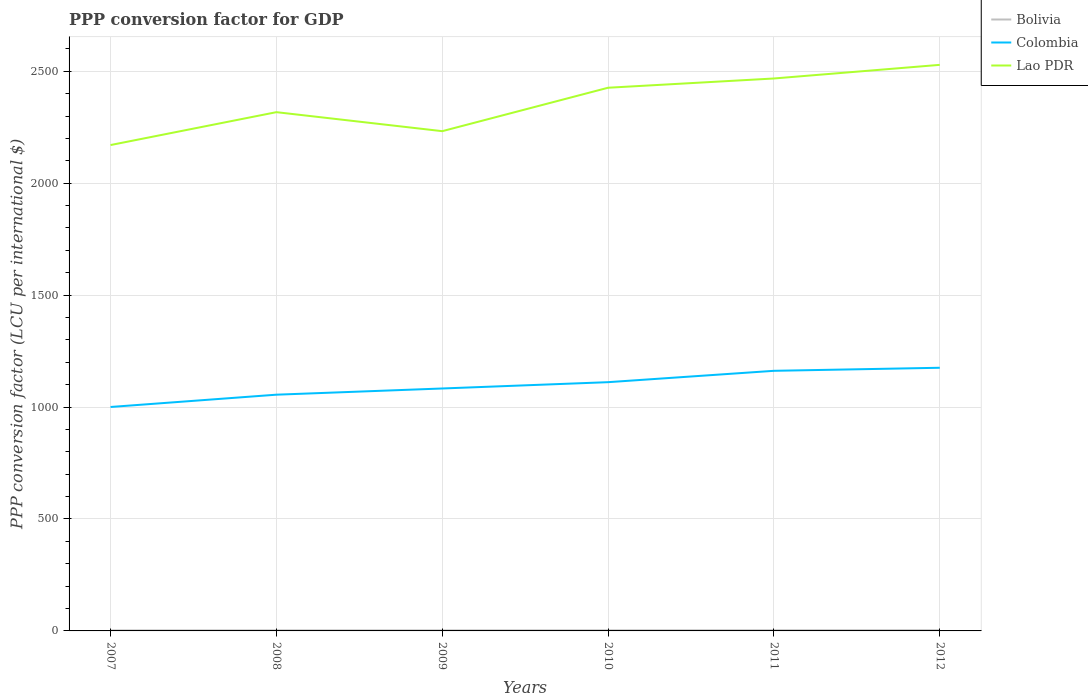Does the line corresponding to Lao PDR intersect with the line corresponding to Colombia?
Ensure brevity in your answer.  No. Is the number of lines equal to the number of legend labels?
Provide a succinct answer. Yes. Across all years, what is the maximum PPP conversion factor for GDP in Lao PDR?
Keep it short and to the point. 2170.38. In which year was the PPP conversion factor for GDP in Colombia maximum?
Offer a very short reply. 2007. What is the total PPP conversion factor for GDP in Bolivia in the graph?
Ensure brevity in your answer.  0.08. What is the difference between the highest and the second highest PPP conversion factor for GDP in Bolivia?
Offer a very short reply. 0.77. What is the difference between the highest and the lowest PPP conversion factor for GDP in Colombia?
Offer a very short reply. 3. How many lines are there?
Offer a terse response. 3. What is the difference between two consecutive major ticks on the Y-axis?
Offer a very short reply. 500. Does the graph contain any zero values?
Offer a terse response. No. Where does the legend appear in the graph?
Offer a terse response. Top right. How are the legend labels stacked?
Give a very brief answer. Vertical. What is the title of the graph?
Ensure brevity in your answer.  PPP conversion factor for GDP. What is the label or title of the Y-axis?
Offer a terse response. PPP conversion factor (LCU per international $). What is the PPP conversion factor (LCU per international $) in Bolivia in 2007?
Give a very brief answer. 2.33. What is the PPP conversion factor (LCU per international $) in Colombia in 2007?
Your response must be concise. 1000.36. What is the PPP conversion factor (LCU per international $) in Lao PDR in 2007?
Offer a very short reply. 2170.38. What is the PPP conversion factor (LCU per international $) in Bolivia in 2008?
Offer a terse response. 2.52. What is the PPP conversion factor (LCU per international $) of Colombia in 2008?
Keep it short and to the point. 1055.24. What is the PPP conversion factor (LCU per international $) of Lao PDR in 2008?
Your answer should be very brief. 2317.3. What is the PPP conversion factor (LCU per international $) of Bolivia in 2009?
Give a very brief answer. 2.44. What is the PPP conversion factor (LCU per international $) of Colombia in 2009?
Give a very brief answer. 1082.98. What is the PPP conversion factor (LCU per international $) of Lao PDR in 2009?
Provide a short and direct response. 2232.4. What is the PPP conversion factor (LCU per international $) of Bolivia in 2010?
Keep it short and to the point. 2.62. What is the PPP conversion factor (LCU per international $) in Colombia in 2010?
Give a very brief answer. 1111.17. What is the PPP conversion factor (LCU per international $) of Lao PDR in 2010?
Provide a short and direct response. 2426.42. What is the PPP conversion factor (LCU per international $) of Bolivia in 2011?
Offer a terse response. 2.95. What is the PPP conversion factor (LCU per international $) in Colombia in 2011?
Your response must be concise. 1161.91. What is the PPP conversion factor (LCU per international $) in Lao PDR in 2011?
Make the answer very short. 2467.75. What is the PPP conversion factor (LCU per international $) of Bolivia in 2012?
Your answer should be very brief. 3.1. What is the PPP conversion factor (LCU per international $) of Colombia in 2012?
Provide a short and direct response. 1175.54. What is the PPP conversion factor (LCU per international $) in Lao PDR in 2012?
Provide a succinct answer. 2528.62. Across all years, what is the maximum PPP conversion factor (LCU per international $) of Bolivia?
Your response must be concise. 3.1. Across all years, what is the maximum PPP conversion factor (LCU per international $) of Colombia?
Keep it short and to the point. 1175.54. Across all years, what is the maximum PPP conversion factor (LCU per international $) of Lao PDR?
Give a very brief answer. 2528.62. Across all years, what is the minimum PPP conversion factor (LCU per international $) in Bolivia?
Give a very brief answer. 2.33. Across all years, what is the minimum PPP conversion factor (LCU per international $) in Colombia?
Keep it short and to the point. 1000.36. Across all years, what is the minimum PPP conversion factor (LCU per international $) of Lao PDR?
Offer a terse response. 2170.38. What is the total PPP conversion factor (LCU per international $) of Bolivia in the graph?
Your response must be concise. 15.96. What is the total PPP conversion factor (LCU per international $) of Colombia in the graph?
Provide a short and direct response. 6587.2. What is the total PPP conversion factor (LCU per international $) of Lao PDR in the graph?
Offer a terse response. 1.41e+04. What is the difference between the PPP conversion factor (LCU per international $) in Bolivia in 2007 and that in 2008?
Provide a succinct answer. -0.19. What is the difference between the PPP conversion factor (LCU per international $) in Colombia in 2007 and that in 2008?
Your response must be concise. -54.88. What is the difference between the PPP conversion factor (LCU per international $) in Lao PDR in 2007 and that in 2008?
Ensure brevity in your answer.  -146.91. What is the difference between the PPP conversion factor (LCU per international $) in Bolivia in 2007 and that in 2009?
Make the answer very short. -0.11. What is the difference between the PPP conversion factor (LCU per international $) of Colombia in 2007 and that in 2009?
Ensure brevity in your answer.  -82.62. What is the difference between the PPP conversion factor (LCU per international $) in Lao PDR in 2007 and that in 2009?
Your answer should be compact. -62.02. What is the difference between the PPP conversion factor (LCU per international $) of Bolivia in 2007 and that in 2010?
Ensure brevity in your answer.  -0.29. What is the difference between the PPP conversion factor (LCU per international $) of Colombia in 2007 and that in 2010?
Provide a succinct answer. -110.81. What is the difference between the PPP conversion factor (LCU per international $) of Lao PDR in 2007 and that in 2010?
Your answer should be very brief. -256.03. What is the difference between the PPP conversion factor (LCU per international $) in Bolivia in 2007 and that in 2011?
Provide a succinct answer. -0.62. What is the difference between the PPP conversion factor (LCU per international $) of Colombia in 2007 and that in 2011?
Your answer should be very brief. -161.55. What is the difference between the PPP conversion factor (LCU per international $) in Lao PDR in 2007 and that in 2011?
Ensure brevity in your answer.  -297.37. What is the difference between the PPP conversion factor (LCU per international $) in Bolivia in 2007 and that in 2012?
Offer a terse response. -0.77. What is the difference between the PPP conversion factor (LCU per international $) in Colombia in 2007 and that in 2012?
Offer a very short reply. -175.18. What is the difference between the PPP conversion factor (LCU per international $) in Lao PDR in 2007 and that in 2012?
Offer a very short reply. -358.24. What is the difference between the PPP conversion factor (LCU per international $) of Bolivia in 2008 and that in 2009?
Provide a short and direct response. 0.08. What is the difference between the PPP conversion factor (LCU per international $) in Colombia in 2008 and that in 2009?
Provide a succinct answer. -27.74. What is the difference between the PPP conversion factor (LCU per international $) in Lao PDR in 2008 and that in 2009?
Keep it short and to the point. 84.9. What is the difference between the PPP conversion factor (LCU per international $) in Bolivia in 2008 and that in 2010?
Your answer should be compact. -0.1. What is the difference between the PPP conversion factor (LCU per international $) of Colombia in 2008 and that in 2010?
Offer a very short reply. -55.93. What is the difference between the PPP conversion factor (LCU per international $) of Lao PDR in 2008 and that in 2010?
Keep it short and to the point. -109.12. What is the difference between the PPP conversion factor (LCU per international $) of Bolivia in 2008 and that in 2011?
Your answer should be very brief. -0.42. What is the difference between the PPP conversion factor (LCU per international $) of Colombia in 2008 and that in 2011?
Provide a short and direct response. -106.67. What is the difference between the PPP conversion factor (LCU per international $) in Lao PDR in 2008 and that in 2011?
Offer a terse response. -150.45. What is the difference between the PPP conversion factor (LCU per international $) of Bolivia in 2008 and that in 2012?
Give a very brief answer. -0.58. What is the difference between the PPP conversion factor (LCU per international $) in Colombia in 2008 and that in 2012?
Offer a terse response. -120.29. What is the difference between the PPP conversion factor (LCU per international $) of Lao PDR in 2008 and that in 2012?
Ensure brevity in your answer.  -211.33. What is the difference between the PPP conversion factor (LCU per international $) in Bolivia in 2009 and that in 2010?
Offer a terse response. -0.18. What is the difference between the PPP conversion factor (LCU per international $) of Colombia in 2009 and that in 2010?
Offer a terse response. -28.19. What is the difference between the PPP conversion factor (LCU per international $) in Lao PDR in 2009 and that in 2010?
Your answer should be very brief. -194.02. What is the difference between the PPP conversion factor (LCU per international $) in Bolivia in 2009 and that in 2011?
Offer a very short reply. -0.5. What is the difference between the PPP conversion factor (LCU per international $) of Colombia in 2009 and that in 2011?
Provide a succinct answer. -78.93. What is the difference between the PPP conversion factor (LCU per international $) in Lao PDR in 2009 and that in 2011?
Your response must be concise. -235.35. What is the difference between the PPP conversion factor (LCU per international $) in Bolivia in 2009 and that in 2012?
Your response must be concise. -0.66. What is the difference between the PPP conversion factor (LCU per international $) of Colombia in 2009 and that in 2012?
Keep it short and to the point. -92.56. What is the difference between the PPP conversion factor (LCU per international $) in Lao PDR in 2009 and that in 2012?
Provide a succinct answer. -296.23. What is the difference between the PPP conversion factor (LCU per international $) of Bolivia in 2010 and that in 2011?
Your answer should be compact. -0.32. What is the difference between the PPP conversion factor (LCU per international $) of Colombia in 2010 and that in 2011?
Your answer should be compact. -50.74. What is the difference between the PPP conversion factor (LCU per international $) in Lao PDR in 2010 and that in 2011?
Provide a succinct answer. -41.34. What is the difference between the PPP conversion factor (LCU per international $) of Bolivia in 2010 and that in 2012?
Make the answer very short. -0.48. What is the difference between the PPP conversion factor (LCU per international $) in Colombia in 2010 and that in 2012?
Offer a terse response. -64.37. What is the difference between the PPP conversion factor (LCU per international $) of Lao PDR in 2010 and that in 2012?
Provide a succinct answer. -102.21. What is the difference between the PPP conversion factor (LCU per international $) of Bolivia in 2011 and that in 2012?
Offer a terse response. -0.15. What is the difference between the PPP conversion factor (LCU per international $) of Colombia in 2011 and that in 2012?
Make the answer very short. -13.63. What is the difference between the PPP conversion factor (LCU per international $) of Lao PDR in 2011 and that in 2012?
Offer a terse response. -60.87. What is the difference between the PPP conversion factor (LCU per international $) of Bolivia in 2007 and the PPP conversion factor (LCU per international $) of Colombia in 2008?
Offer a very short reply. -1052.91. What is the difference between the PPP conversion factor (LCU per international $) in Bolivia in 2007 and the PPP conversion factor (LCU per international $) in Lao PDR in 2008?
Your answer should be compact. -2314.97. What is the difference between the PPP conversion factor (LCU per international $) of Colombia in 2007 and the PPP conversion factor (LCU per international $) of Lao PDR in 2008?
Keep it short and to the point. -1316.94. What is the difference between the PPP conversion factor (LCU per international $) in Bolivia in 2007 and the PPP conversion factor (LCU per international $) in Colombia in 2009?
Offer a very short reply. -1080.65. What is the difference between the PPP conversion factor (LCU per international $) in Bolivia in 2007 and the PPP conversion factor (LCU per international $) in Lao PDR in 2009?
Offer a very short reply. -2230.07. What is the difference between the PPP conversion factor (LCU per international $) in Colombia in 2007 and the PPP conversion factor (LCU per international $) in Lao PDR in 2009?
Give a very brief answer. -1232.04. What is the difference between the PPP conversion factor (LCU per international $) of Bolivia in 2007 and the PPP conversion factor (LCU per international $) of Colombia in 2010?
Provide a short and direct response. -1108.84. What is the difference between the PPP conversion factor (LCU per international $) in Bolivia in 2007 and the PPP conversion factor (LCU per international $) in Lao PDR in 2010?
Give a very brief answer. -2424.09. What is the difference between the PPP conversion factor (LCU per international $) in Colombia in 2007 and the PPP conversion factor (LCU per international $) in Lao PDR in 2010?
Provide a short and direct response. -1426.06. What is the difference between the PPP conversion factor (LCU per international $) of Bolivia in 2007 and the PPP conversion factor (LCU per international $) of Colombia in 2011?
Give a very brief answer. -1159.58. What is the difference between the PPP conversion factor (LCU per international $) in Bolivia in 2007 and the PPP conversion factor (LCU per international $) in Lao PDR in 2011?
Make the answer very short. -2465.42. What is the difference between the PPP conversion factor (LCU per international $) of Colombia in 2007 and the PPP conversion factor (LCU per international $) of Lao PDR in 2011?
Give a very brief answer. -1467.39. What is the difference between the PPP conversion factor (LCU per international $) of Bolivia in 2007 and the PPP conversion factor (LCU per international $) of Colombia in 2012?
Your answer should be compact. -1173.21. What is the difference between the PPP conversion factor (LCU per international $) of Bolivia in 2007 and the PPP conversion factor (LCU per international $) of Lao PDR in 2012?
Provide a succinct answer. -2526.3. What is the difference between the PPP conversion factor (LCU per international $) of Colombia in 2007 and the PPP conversion factor (LCU per international $) of Lao PDR in 2012?
Your answer should be very brief. -1528.27. What is the difference between the PPP conversion factor (LCU per international $) of Bolivia in 2008 and the PPP conversion factor (LCU per international $) of Colombia in 2009?
Offer a terse response. -1080.46. What is the difference between the PPP conversion factor (LCU per international $) of Bolivia in 2008 and the PPP conversion factor (LCU per international $) of Lao PDR in 2009?
Provide a short and direct response. -2229.88. What is the difference between the PPP conversion factor (LCU per international $) of Colombia in 2008 and the PPP conversion factor (LCU per international $) of Lao PDR in 2009?
Your response must be concise. -1177.16. What is the difference between the PPP conversion factor (LCU per international $) in Bolivia in 2008 and the PPP conversion factor (LCU per international $) in Colombia in 2010?
Offer a very short reply. -1108.65. What is the difference between the PPP conversion factor (LCU per international $) in Bolivia in 2008 and the PPP conversion factor (LCU per international $) in Lao PDR in 2010?
Ensure brevity in your answer.  -2423.9. What is the difference between the PPP conversion factor (LCU per international $) in Colombia in 2008 and the PPP conversion factor (LCU per international $) in Lao PDR in 2010?
Your response must be concise. -1371.17. What is the difference between the PPP conversion factor (LCU per international $) in Bolivia in 2008 and the PPP conversion factor (LCU per international $) in Colombia in 2011?
Your answer should be very brief. -1159.39. What is the difference between the PPP conversion factor (LCU per international $) in Bolivia in 2008 and the PPP conversion factor (LCU per international $) in Lao PDR in 2011?
Keep it short and to the point. -2465.23. What is the difference between the PPP conversion factor (LCU per international $) in Colombia in 2008 and the PPP conversion factor (LCU per international $) in Lao PDR in 2011?
Provide a short and direct response. -1412.51. What is the difference between the PPP conversion factor (LCU per international $) of Bolivia in 2008 and the PPP conversion factor (LCU per international $) of Colombia in 2012?
Offer a very short reply. -1173.01. What is the difference between the PPP conversion factor (LCU per international $) in Bolivia in 2008 and the PPP conversion factor (LCU per international $) in Lao PDR in 2012?
Offer a very short reply. -2526.1. What is the difference between the PPP conversion factor (LCU per international $) of Colombia in 2008 and the PPP conversion factor (LCU per international $) of Lao PDR in 2012?
Ensure brevity in your answer.  -1473.38. What is the difference between the PPP conversion factor (LCU per international $) in Bolivia in 2009 and the PPP conversion factor (LCU per international $) in Colombia in 2010?
Offer a very short reply. -1108.73. What is the difference between the PPP conversion factor (LCU per international $) in Bolivia in 2009 and the PPP conversion factor (LCU per international $) in Lao PDR in 2010?
Ensure brevity in your answer.  -2423.98. What is the difference between the PPP conversion factor (LCU per international $) in Colombia in 2009 and the PPP conversion factor (LCU per international $) in Lao PDR in 2010?
Offer a terse response. -1343.44. What is the difference between the PPP conversion factor (LCU per international $) of Bolivia in 2009 and the PPP conversion factor (LCU per international $) of Colombia in 2011?
Provide a short and direct response. -1159.47. What is the difference between the PPP conversion factor (LCU per international $) of Bolivia in 2009 and the PPP conversion factor (LCU per international $) of Lao PDR in 2011?
Provide a short and direct response. -2465.31. What is the difference between the PPP conversion factor (LCU per international $) in Colombia in 2009 and the PPP conversion factor (LCU per international $) in Lao PDR in 2011?
Provide a short and direct response. -1384.77. What is the difference between the PPP conversion factor (LCU per international $) of Bolivia in 2009 and the PPP conversion factor (LCU per international $) of Colombia in 2012?
Ensure brevity in your answer.  -1173.09. What is the difference between the PPP conversion factor (LCU per international $) of Bolivia in 2009 and the PPP conversion factor (LCU per international $) of Lao PDR in 2012?
Provide a succinct answer. -2526.18. What is the difference between the PPP conversion factor (LCU per international $) of Colombia in 2009 and the PPP conversion factor (LCU per international $) of Lao PDR in 2012?
Keep it short and to the point. -1445.65. What is the difference between the PPP conversion factor (LCU per international $) in Bolivia in 2010 and the PPP conversion factor (LCU per international $) in Colombia in 2011?
Ensure brevity in your answer.  -1159.29. What is the difference between the PPP conversion factor (LCU per international $) in Bolivia in 2010 and the PPP conversion factor (LCU per international $) in Lao PDR in 2011?
Keep it short and to the point. -2465.13. What is the difference between the PPP conversion factor (LCU per international $) of Colombia in 2010 and the PPP conversion factor (LCU per international $) of Lao PDR in 2011?
Give a very brief answer. -1356.58. What is the difference between the PPP conversion factor (LCU per international $) of Bolivia in 2010 and the PPP conversion factor (LCU per international $) of Colombia in 2012?
Give a very brief answer. -1172.91. What is the difference between the PPP conversion factor (LCU per international $) of Bolivia in 2010 and the PPP conversion factor (LCU per international $) of Lao PDR in 2012?
Your answer should be very brief. -2526. What is the difference between the PPP conversion factor (LCU per international $) in Colombia in 2010 and the PPP conversion factor (LCU per international $) in Lao PDR in 2012?
Offer a terse response. -1417.45. What is the difference between the PPP conversion factor (LCU per international $) in Bolivia in 2011 and the PPP conversion factor (LCU per international $) in Colombia in 2012?
Ensure brevity in your answer.  -1172.59. What is the difference between the PPP conversion factor (LCU per international $) of Bolivia in 2011 and the PPP conversion factor (LCU per international $) of Lao PDR in 2012?
Offer a terse response. -2525.68. What is the difference between the PPP conversion factor (LCU per international $) in Colombia in 2011 and the PPP conversion factor (LCU per international $) in Lao PDR in 2012?
Make the answer very short. -1366.72. What is the average PPP conversion factor (LCU per international $) of Bolivia per year?
Ensure brevity in your answer.  2.66. What is the average PPP conversion factor (LCU per international $) in Colombia per year?
Make the answer very short. 1097.87. What is the average PPP conversion factor (LCU per international $) of Lao PDR per year?
Ensure brevity in your answer.  2357.15. In the year 2007, what is the difference between the PPP conversion factor (LCU per international $) in Bolivia and PPP conversion factor (LCU per international $) in Colombia?
Provide a short and direct response. -998.03. In the year 2007, what is the difference between the PPP conversion factor (LCU per international $) of Bolivia and PPP conversion factor (LCU per international $) of Lao PDR?
Provide a succinct answer. -2168.05. In the year 2007, what is the difference between the PPP conversion factor (LCU per international $) in Colombia and PPP conversion factor (LCU per international $) in Lao PDR?
Your answer should be very brief. -1170.03. In the year 2008, what is the difference between the PPP conversion factor (LCU per international $) of Bolivia and PPP conversion factor (LCU per international $) of Colombia?
Give a very brief answer. -1052.72. In the year 2008, what is the difference between the PPP conversion factor (LCU per international $) of Bolivia and PPP conversion factor (LCU per international $) of Lao PDR?
Give a very brief answer. -2314.78. In the year 2008, what is the difference between the PPP conversion factor (LCU per international $) of Colombia and PPP conversion factor (LCU per international $) of Lao PDR?
Keep it short and to the point. -1262.06. In the year 2009, what is the difference between the PPP conversion factor (LCU per international $) in Bolivia and PPP conversion factor (LCU per international $) in Colombia?
Give a very brief answer. -1080.54. In the year 2009, what is the difference between the PPP conversion factor (LCU per international $) of Bolivia and PPP conversion factor (LCU per international $) of Lao PDR?
Provide a short and direct response. -2229.96. In the year 2009, what is the difference between the PPP conversion factor (LCU per international $) in Colombia and PPP conversion factor (LCU per international $) in Lao PDR?
Keep it short and to the point. -1149.42. In the year 2010, what is the difference between the PPP conversion factor (LCU per international $) of Bolivia and PPP conversion factor (LCU per international $) of Colombia?
Make the answer very short. -1108.55. In the year 2010, what is the difference between the PPP conversion factor (LCU per international $) of Bolivia and PPP conversion factor (LCU per international $) of Lao PDR?
Offer a terse response. -2423.79. In the year 2010, what is the difference between the PPP conversion factor (LCU per international $) in Colombia and PPP conversion factor (LCU per international $) in Lao PDR?
Give a very brief answer. -1315.25. In the year 2011, what is the difference between the PPP conversion factor (LCU per international $) of Bolivia and PPP conversion factor (LCU per international $) of Colombia?
Ensure brevity in your answer.  -1158.96. In the year 2011, what is the difference between the PPP conversion factor (LCU per international $) in Bolivia and PPP conversion factor (LCU per international $) in Lao PDR?
Offer a very short reply. -2464.81. In the year 2011, what is the difference between the PPP conversion factor (LCU per international $) of Colombia and PPP conversion factor (LCU per international $) of Lao PDR?
Offer a very short reply. -1305.84. In the year 2012, what is the difference between the PPP conversion factor (LCU per international $) in Bolivia and PPP conversion factor (LCU per international $) in Colombia?
Provide a succinct answer. -1172.44. In the year 2012, what is the difference between the PPP conversion factor (LCU per international $) in Bolivia and PPP conversion factor (LCU per international $) in Lao PDR?
Ensure brevity in your answer.  -2525.53. In the year 2012, what is the difference between the PPP conversion factor (LCU per international $) in Colombia and PPP conversion factor (LCU per international $) in Lao PDR?
Your answer should be very brief. -1353.09. What is the ratio of the PPP conversion factor (LCU per international $) in Bolivia in 2007 to that in 2008?
Offer a terse response. 0.92. What is the ratio of the PPP conversion factor (LCU per international $) in Colombia in 2007 to that in 2008?
Your response must be concise. 0.95. What is the ratio of the PPP conversion factor (LCU per international $) in Lao PDR in 2007 to that in 2008?
Your answer should be very brief. 0.94. What is the ratio of the PPP conversion factor (LCU per international $) of Bolivia in 2007 to that in 2009?
Your response must be concise. 0.95. What is the ratio of the PPP conversion factor (LCU per international $) of Colombia in 2007 to that in 2009?
Offer a terse response. 0.92. What is the ratio of the PPP conversion factor (LCU per international $) of Lao PDR in 2007 to that in 2009?
Your answer should be compact. 0.97. What is the ratio of the PPP conversion factor (LCU per international $) in Bolivia in 2007 to that in 2010?
Keep it short and to the point. 0.89. What is the ratio of the PPP conversion factor (LCU per international $) in Colombia in 2007 to that in 2010?
Your answer should be compact. 0.9. What is the ratio of the PPP conversion factor (LCU per international $) in Lao PDR in 2007 to that in 2010?
Ensure brevity in your answer.  0.89. What is the ratio of the PPP conversion factor (LCU per international $) of Bolivia in 2007 to that in 2011?
Provide a short and direct response. 0.79. What is the ratio of the PPP conversion factor (LCU per international $) of Colombia in 2007 to that in 2011?
Offer a very short reply. 0.86. What is the ratio of the PPP conversion factor (LCU per international $) of Lao PDR in 2007 to that in 2011?
Your response must be concise. 0.88. What is the ratio of the PPP conversion factor (LCU per international $) of Bolivia in 2007 to that in 2012?
Your response must be concise. 0.75. What is the ratio of the PPP conversion factor (LCU per international $) in Colombia in 2007 to that in 2012?
Ensure brevity in your answer.  0.85. What is the ratio of the PPP conversion factor (LCU per international $) in Lao PDR in 2007 to that in 2012?
Offer a very short reply. 0.86. What is the ratio of the PPP conversion factor (LCU per international $) of Bolivia in 2008 to that in 2009?
Your answer should be compact. 1.03. What is the ratio of the PPP conversion factor (LCU per international $) in Colombia in 2008 to that in 2009?
Offer a very short reply. 0.97. What is the ratio of the PPP conversion factor (LCU per international $) of Lao PDR in 2008 to that in 2009?
Offer a very short reply. 1.04. What is the ratio of the PPP conversion factor (LCU per international $) of Bolivia in 2008 to that in 2010?
Give a very brief answer. 0.96. What is the ratio of the PPP conversion factor (LCU per international $) of Colombia in 2008 to that in 2010?
Provide a succinct answer. 0.95. What is the ratio of the PPP conversion factor (LCU per international $) of Lao PDR in 2008 to that in 2010?
Your answer should be very brief. 0.95. What is the ratio of the PPP conversion factor (LCU per international $) of Bolivia in 2008 to that in 2011?
Offer a terse response. 0.86. What is the ratio of the PPP conversion factor (LCU per international $) of Colombia in 2008 to that in 2011?
Provide a succinct answer. 0.91. What is the ratio of the PPP conversion factor (LCU per international $) in Lao PDR in 2008 to that in 2011?
Offer a very short reply. 0.94. What is the ratio of the PPP conversion factor (LCU per international $) of Bolivia in 2008 to that in 2012?
Offer a terse response. 0.81. What is the ratio of the PPP conversion factor (LCU per international $) in Colombia in 2008 to that in 2012?
Ensure brevity in your answer.  0.9. What is the ratio of the PPP conversion factor (LCU per international $) in Lao PDR in 2008 to that in 2012?
Offer a very short reply. 0.92. What is the ratio of the PPP conversion factor (LCU per international $) of Bolivia in 2009 to that in 2010?
Make the answer very short. 0.93. What is the ratio of the PPP conversion factor (LCU per international $) in Colombia in 2009 to that in 2010?
Offer a terse response. 0.97. What is the ratio of the PPP conversion factor (LCU per international $) of Bolivia in 2009 to that in 2011?
Keep it short and to the point. 0.83. What is the ratio of the PPP conversion factor (LCU per international $) of Colombia in 2009 to that in 2011?
Your answer should be compact. 0.93. What is the ratio of the PPP conversion factor (LCU per international $) in Lao PDR in 2009 to that in 2011?
Offer a terse response. 0.9. What is the ratio of the PPP conversion factor (LCU per international $) in Bolivia in 2009 to that in 2012?
Keep it short and to the point. 0.79. What is the ratio of the PPP conversion factor (LCU per international $) in Colombia in 2009 to that in 2012?
Keep it short and to the point. 0.92. What is the ratio of the PPP conversion factor (LCU per international $) of Lao PDR in 2009 to that in 2012?
Give a very brief answer. 0.88. What is the ratio of the PPP conversion factor (LCU per international $) of Bolivia in 2010 to that in 2011?
Offer a very short reply. 0.89. What is the ratio of the PPP conversion factor (LCU per international $) in Colombia in 2010 to that in 2011?
Provide a succinct answer. 0.96. What is the ratio of the PPP conversion factor (LCU per international $) of Lao PDR in 2010 to that in 2011?
Your answer should be very brief. 0.98. What is the ratio of the PPP conversion factor (LCU per international $) in Bolivia in 2010 to that in 2012?
Keep it short and to the point. 0.85. What is the ratio of the PPP conversion factor (LCU per international $) in Colombia in 2010 to that in 2012?
Offer a terse response. 0.95. What is the ratio of the PPP conversion factor (LCU per international $) in Lao PDR in 2010 to that in 2012?
Make the answer very short. 0.96. What is the ratio of the PPP conversion factor (LCU per international $) of Bolivia in 2011 to that in 2012?
Ensure brevity in your answer.  0.95. What is the ratio of the PPP conversion factor (LCU per international $) of Colombia in 2011 to that in 2012?
Your response must be concise. 0.99. What is the ratio of the PPP conversion factor (LCU per international $) in Lao PDR in 2011 to that in 2012?
Offer a terse response. 0.98. What is the difference between the highest and the second highest PPP conversion factor (LCU per international $) of Bolivia?
Give a very brief answer. 0.15. What is the difference between the highest and the second highest PPP conversion factor (LCU per international $) in Colombia?
Provide a short and direct response. 13.63. What is the difference between the highest and the second highest PPP conversion factor (LCU per international $) in Lao PDR?
Your response must be concise. 60.87. What is the difference between the highest and the lowest PPP conversion factor (LCU per international $) in Bolivia?
Provide a succinct answer. 0.77. What is the difference between the highest and the lowest PPP conversion factor (LCU per international $) of Colombia?
Your answer should be very brief. 175.18. What is the difference between the highest and the lowest PPP conversion factor (LCU per international $) in Lao PDR?
Make the answer very short. 358.24. 